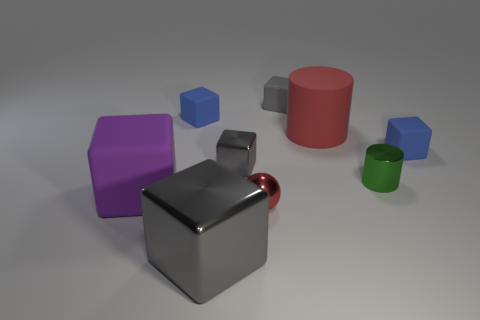There is a large block that is in front of the red ball; does it have the same color as the small metal thing behind the green shiny cylinder?
Your response must be concise. Yes. Is the number of red matte cylinders behind the tiny red shiny object less than the number of small metal balls?
Your answer should be very brief. No. What number of things are large purple objects or blue objects on the left side of the sphere?
Keep it short and to the point. 2. There is a big thing that is made of the same material as the large red cylinder; what is its color?
Ensure brevity in your answer.  Purple. What number of objects are purple rubber cubes or small matte objects?
Your response must be concise. 4. What is the color of the shiny ball that is the same size as the green cylinder?
Your response must be concise. Red. What number of objects are either blue rubber cubes that are on the right side of the shiny sphere or big purple spheres?
Provide a succinct answer. 1. How many other things are there of the same size as the purple matte object?
Keep it short and to the point. 2. There is a blue rubber block on the left side of the small red ball; how big is it?
Keep it short and to the point. Small. The big red object that is the same material as the purple cube is what shape?
Your answer should be compact. Cylinder. 